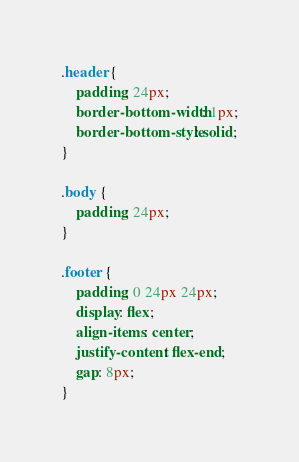<code> <loc_0><loc_0><loc_500><loc_500><_CSS_>.header {
	padding: 24px;
	border-bottom-width: 1px;
	border-bottom-style: solid;
}

.body {
	padding: 24px;
}

.footer {
	padding: 0 24px 24px;
	display: flex;
	align-items: center;
	justify-content: flex-end;
	gap: 8px;
}
</code> 